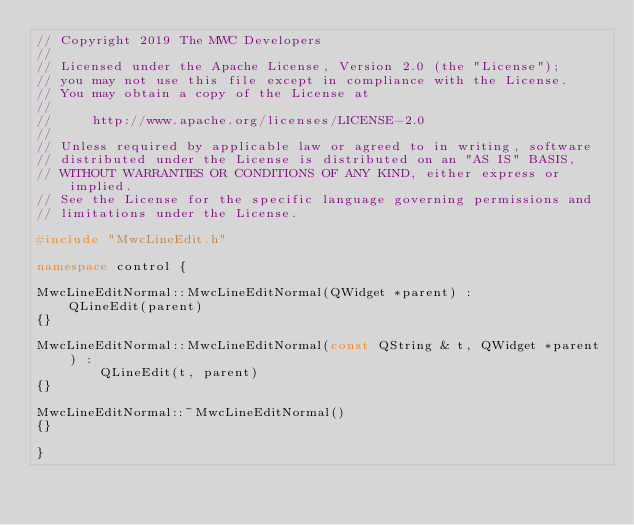Convert code to text. <code><loc_0><loc_0><loc_500><loc_500><_C++_>// Copyright 2019 The MWC Developers
//
// Licensed under the Apache License, Version 2.0 (the "License");
// you may not use this file except in compliance with the License.
// You may obtain a copy of the License at
//
//     http://www.apache.org/licenses/LICENSE-2.0
//
// Unless required by applicable law or agreed to in writing, software
// distributed under the License is distributed on an "AS IS" BASIS,
// WITHOUT WARRANTIES OR CONDITIONS OF ANY KIND, either express or implied.
// See the License for the specific language governing permissions and
// limitations under the License.

#include "MwcLineEdit.h"

namespace control {

MwcLineEditNormal::MwcLineEditNormal(QWidget *parent) :
    QLineEdit(parent)
{}

MwcLineEditNormal::MwcLineEditNormal(const QString & t, QWidget *parent ) :
        QLineEdit(t, parent)
{}

MwcLineEditNormal::~MwcLineEditNormal()
{}

}
</code> 